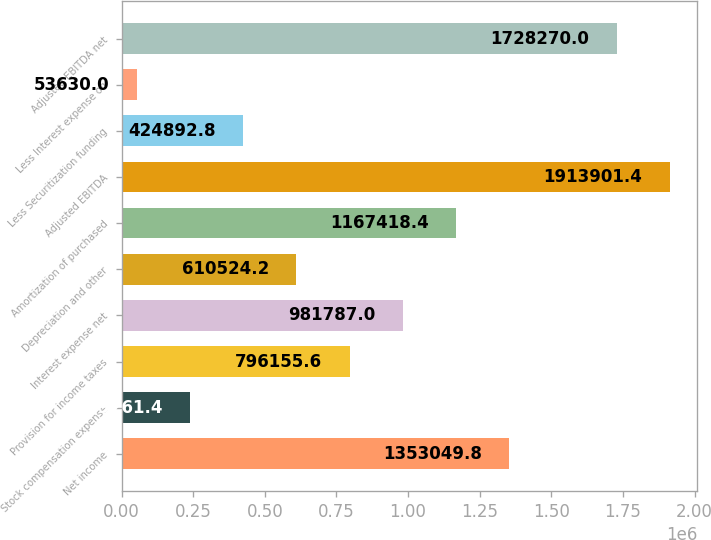<chart> <loc_0><loc_0><loc_500><loc_500><bar_chart><fcel>Net income<fcel>Stock compensation expense<fcel>Provision for income taxes<fcel>Interest expense net<fcel>Depreciation and other<fcel>Amortization of purchased<fcel>Adjusted EBITDA<fcel>Less Securitization funding<fcel>Less Interest expense on<fcel>Adjusted EBITDA net<nl><fcel>1.35305e+06<fcel>239261<fcel>796156<fcel>981787<fcel>610524<fcel>1.16742e+06<fcel>1.9139e+06<fcel>424893<fcel>53630<fcel>1.72827e+06<nl></chart> 